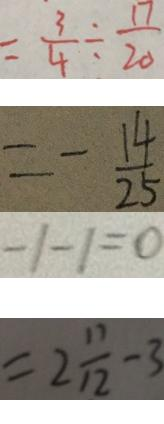<formula> <loc_0><loc_0><loc_500><loc_500>= \frac { 3 } { 4 } \div \frac { 1 7 } { 2 0 } 
 = - \frac { 1 4 } { 2 5 } 
 - 1 - 1 = 0 
 = 2 \frac { 1 1 } { 1 2 } - 3</formula> 